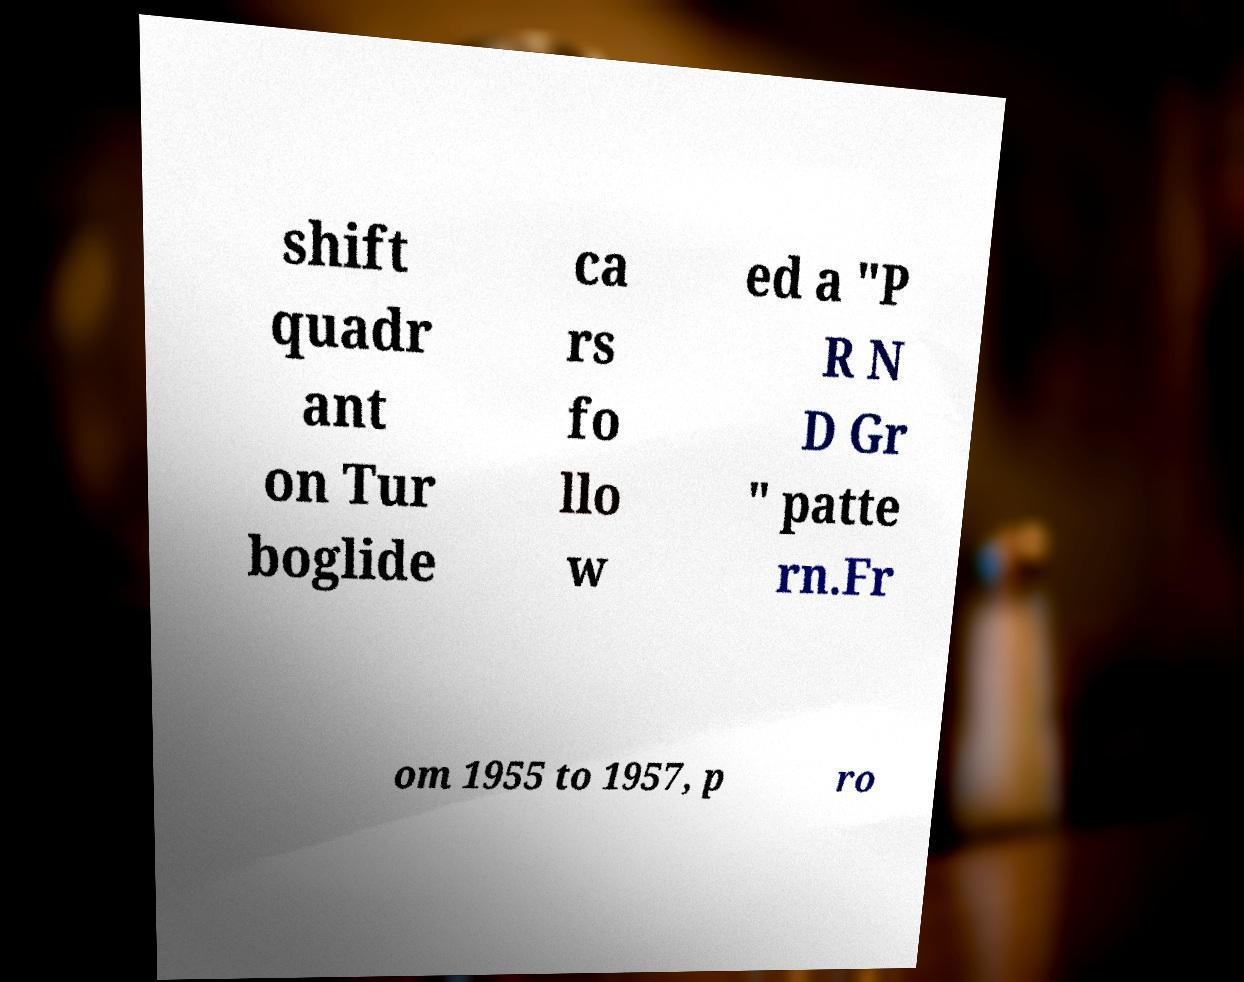Please read and relay the text visible in this image. What does it say? shift quadr ant on Tur boglide ca rs fo llo w ed a "P R N D Gr " patte rn.Fr om 1955 to 1957, p ro 